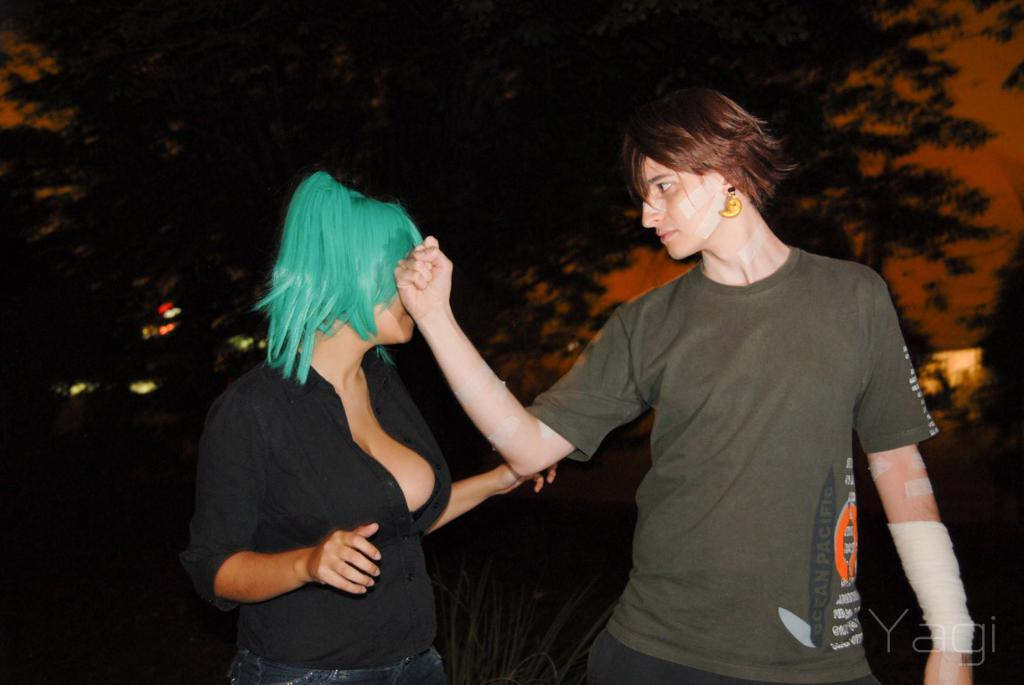How many people are in the image? There are two persons standing in the image. What is the surface they are standing on? The persons are standing on the ground. What can be seen in the background of the image? There is sky, trees, and grass visible in the background of the image. What type of lumber is being used to build the trail in the image? There is no trail or lumber present in the image; it features two persons standing on the ground with a background of sky, trees, and grass. 